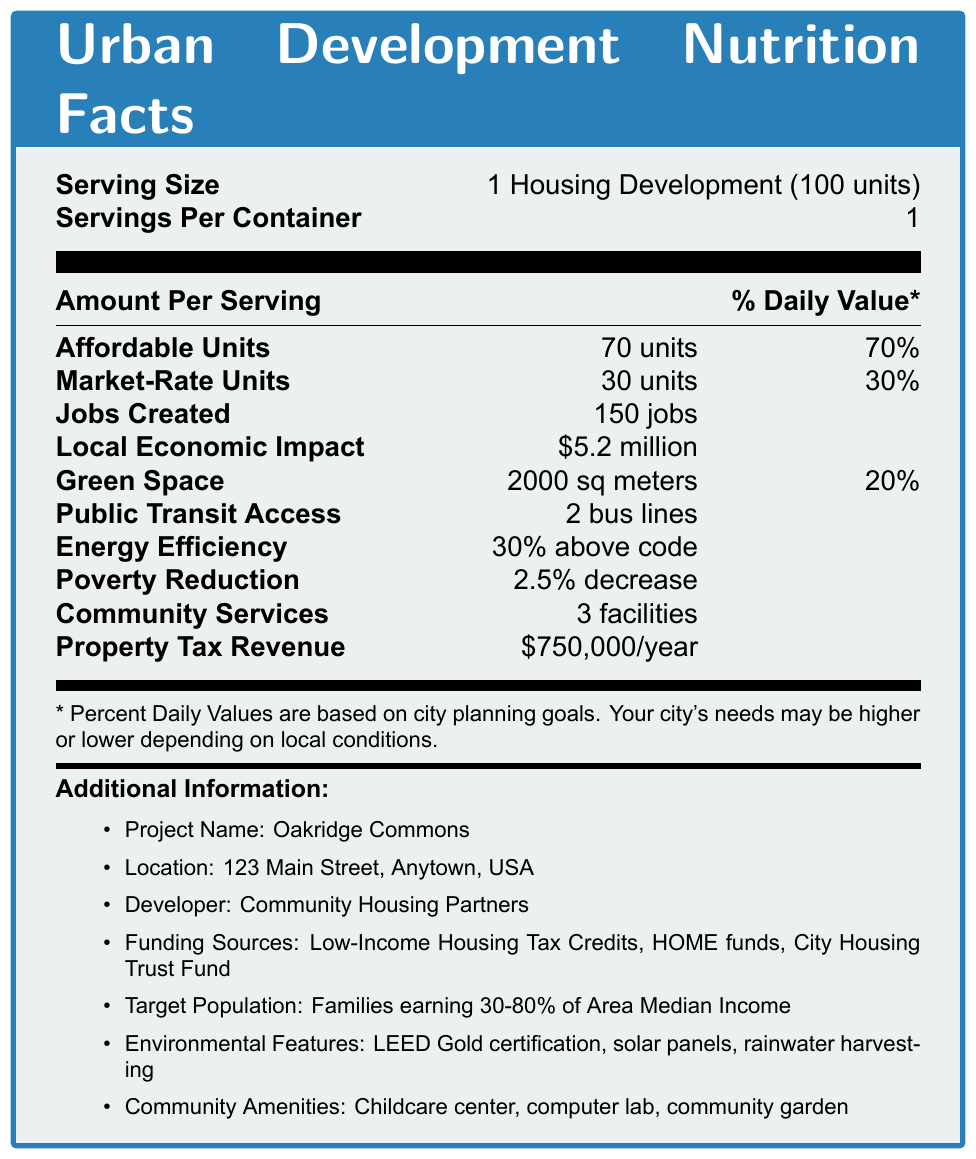What is the serving size for the proposed housing development? The serving size is mentioned at the beginning of the document as "1 Housing Development (100 units)".
Answer: 1 Housing Development (100 units) How many units in total are provided by the development? The document mentions 70 affordable units and 30 market-rate units, summing up to 100 units.
Answer: 100 units What is the location of the proposed housing development? The location is provided under "Additional Information".
Answer: 123 Main Street, Anytown, USA What percentage of the units are affordable? The document indicates 70 affordable units out of 100, which is 70%.
Answer: 70% How much green space is provided? The amount of green space mentioned in the document is 2000 sq meters.
Answer: 2000 sq meters How many bus lines provide access to public transit? The document states that there are 2 bus lines for public transit access.
Answer: 2 bus lines What is the economic impact of the development in monetary terms? The local economic impact is listed as \$5.2 million.
Answer: \$5.2 million How many jobs are created by the housing development? The document specifies that 150 jobs are created.
Answer: 150 jobs Which certification does the document mention regarding environmental features? The environmental features listed include LEED Gold certification.
Answer: LEED Gold certification Which of the following shows the target population for the housing development? A. Senior Citizens B. Students C. Families earning 30-80% of Area Median Income D. Individuals with disabilities The document specifies that the target population is families earning 30-80% of the Area Median Income.
Answer: C. Families earning 30-80% of Area Median Income How much property tax revenue is generated annually by this development? The document states the property tax revenue is \$750,000 per year.
Answer: \$750,000/year Does the housing development include a community garden? Under "Community Amenities", the document lists a community garden.
Answer: Yes Which of the following is *not* a funding source for the development? I. Low-Income Housing Tax Credits II. Federal Emergency Management Agency (FEMA) funds III. HOME funds IV. City Housing Trust Fund The funding sources listed are Low-Income Housing Tax Credits, HOME funds, and City Housing Trust Fund, but not FEMA funds.
Answer: II. Federal Emergency Management Agency (FEMA) funds Provide a summary of the document. The document is a detailed summary of the proposed "Oakridge Commons" housing development, focusing on various metrics and project details.
Answer: The document outlines the details of the "Oakridge Commons" housing development, which includes 100 units, 70 of which are affordable. It details various socioeconomic impact metrics such as jobs created, local economic impact, green space, public transit access, and energy efficiency. Additional information includes the location, developer, funding sources, target population, environmental features, and community amenities. What is the expected reduction in poverty due to this development? The document lists a 2.5% decrease in poverty.
Answer: 2.5% decrease What percentage above code is the energy efficiency for this development? The document states that the energy efficiency is 30% above code.
Answer: 30% above code What is the phone number for the developer "Community Housing Partners"? The document does not provide contact details such as a phone number for the developer.
Answer: Not enough information What type of daily values are the percentages in the document based on? The footnote states that the percent daily values are based on city planning goals.
Answer: City planning goals 